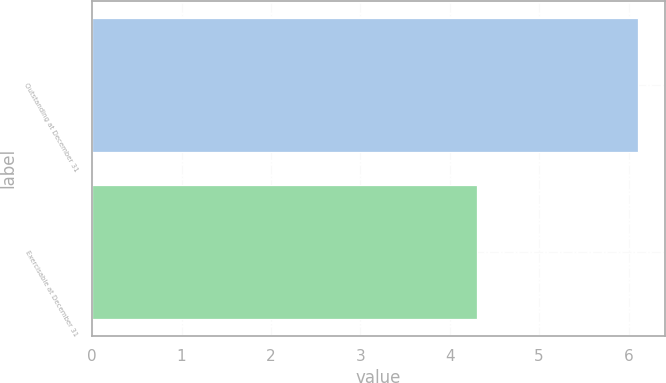Convert chart to OTSL. <chart><loc_0><loc_0><loc_500><loc_500><bar_chart><fcel>Outstanding at December 31<fcel>Exercisable at December 31<nl><fcel>6.1<fcel>4.3<nl></chart> 